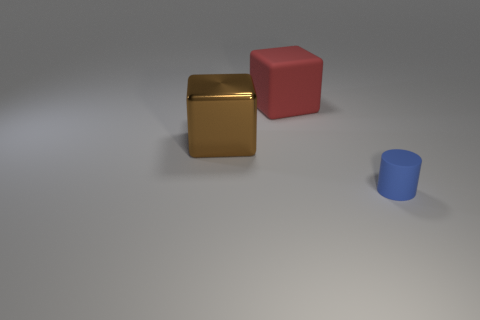What can you tell me about the lighting in this scene? The lighting in the scene appears to be diffused, with soft shadows indicating an overhead and possibly a slight angle source, creating a calm and gentle ambiance. 